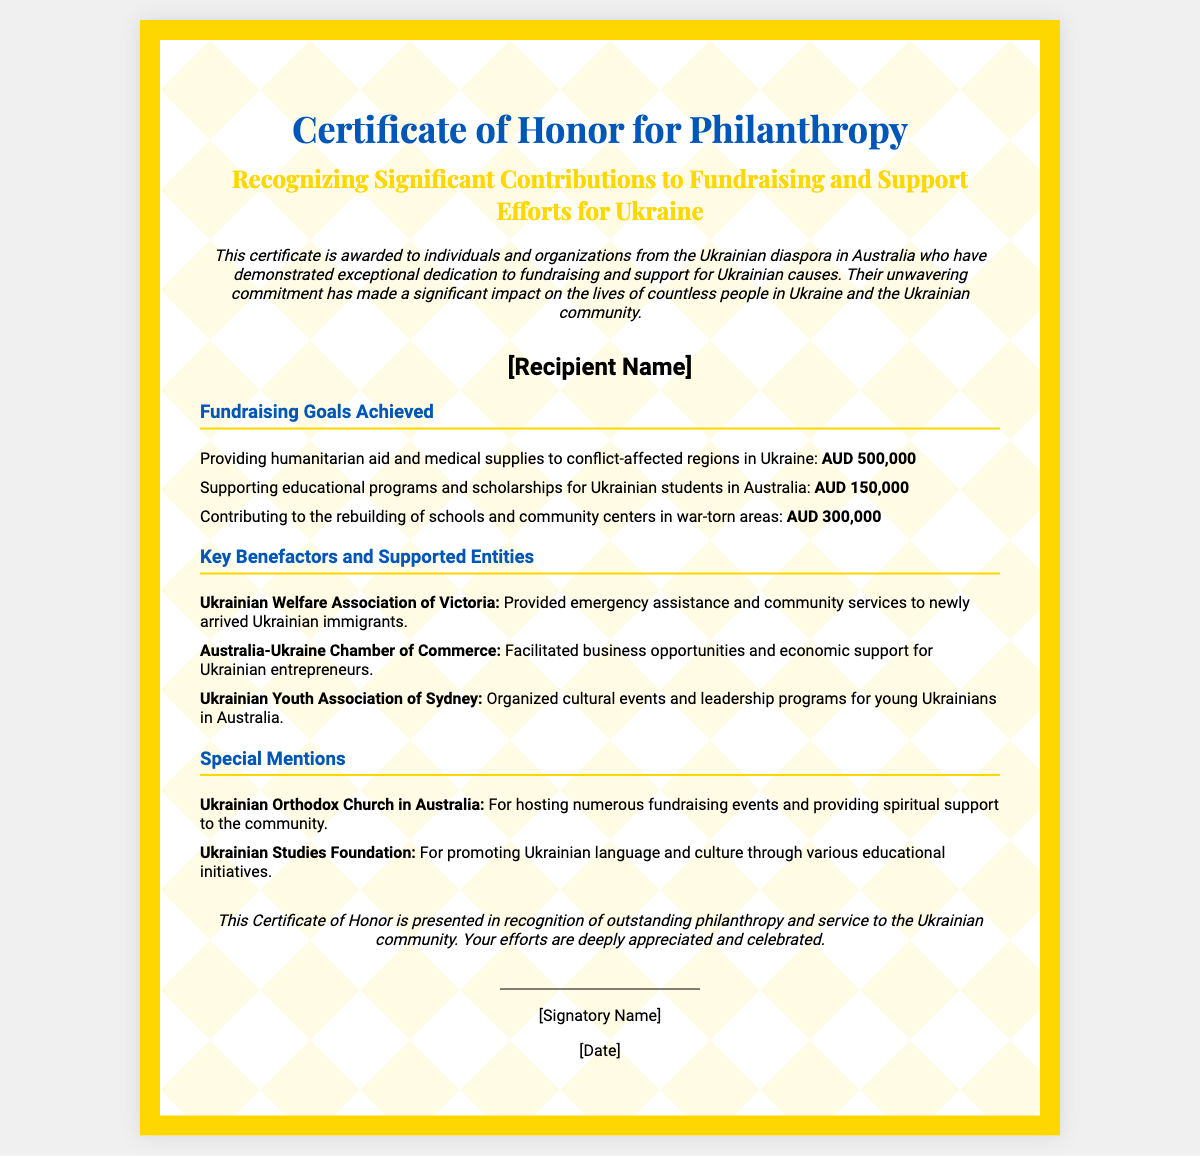what is the title of the certificate? The title is clearly stated at the top of the document, identifying the purpose of the certificate.
Answer: Certificate of Honor for Philanthropy who is the certificate awarded to? The document includes a placeholder for the recipient's name, indicating to whom the recognition is given.
Answer: [Recipient Name] how much was raised for humanitarian aid and medical supplies? The specific amount raised for this cause is listed under fundraising goals in the document.
Answer: AUD 500,000 what is one of the key benefactors mentioned? The document lists organizations that received support, providing specific names under the key benefactors section.
Answer: Ukrainian Welfare Association of Victoria how much was raised for educational programs and scholarships? This information can be found in the fundraising goals section, specifying the amount allocated for educational support.
Answer: AUD 150,000 what kind of programs did the Ukrainian Youth Association of Sydney organize? The document outlines the type of activities the association is involved with under key benefactors and supported entities.
Answer: Cultural events and leadership programs which organization hosted numerous fundraising events? The certificate highlights specific organizations and their contributions, including one that hosted events.
Answer: Ukrainian Orthodox Church in Australia what is the purpose of this certificate? The introductory description clarifies why the certificate is being awarded and the significance of the contributions recognized.
Answer: Recognizing Significant Contributions to Fundraising and Support Efforts for Ukraine who signs the certificate? The document contains a section for a signatory, indicating who officially presents the certificate.
Answer: [Signatory Name] 